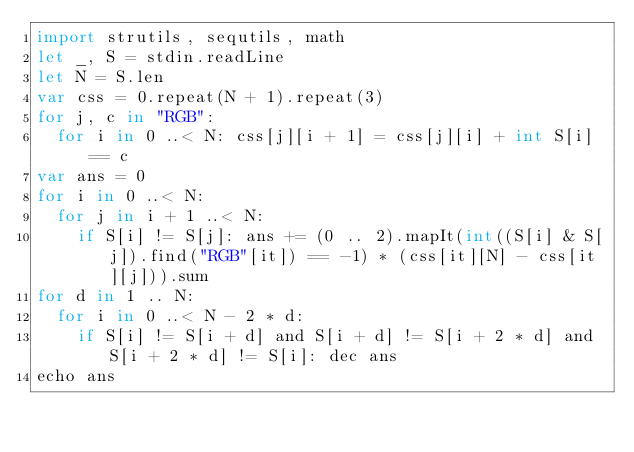Convert code to text. <code><loc_0><loc_0><loc_500><loc_500><_Nim_>import strutils, sequtils, math
let _, S = stdin.readLine
let N = S.len
var css = 0.repeat(N + 1).repeat(3)
for j, c in "RGB":
  for i in 0 ..< N: css[j][i + 1] = css[j][i] + int S[i] == c
var ans = 0
for i in 0 ..< N:
  for j in i + 1 ..< N:
    if S[i] != S[j]: ans += (0 .. 2).mapIt(int((S[i] & S[j]).find("RGB"[it]) == -1) * (css[it][N] - css[it][j])).sum
for d in 1 .. N:
  for i in 0 ..< N - 2 * d:
    if S[i] != S[i + d] and S[i + d] != S[i + 2 * d] and S[i + 2 * d] != S[i]: dec ans
echo ans</code> 